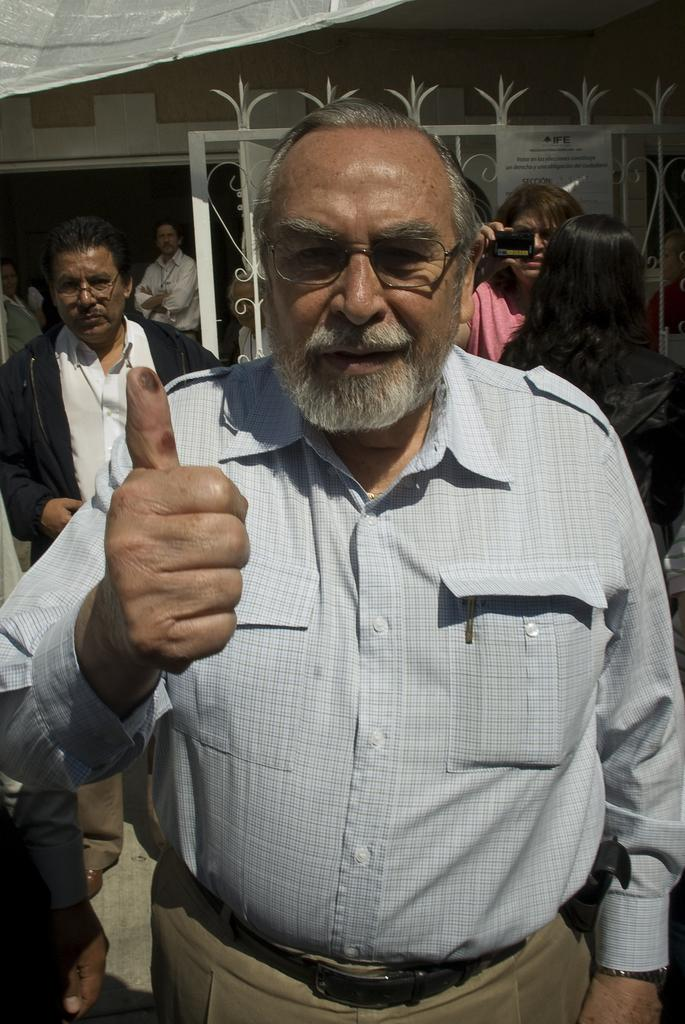How many people are in the image? There are people standing in the image, but the exact number is not specified. What is one person doing in the image? One person is holding a camera. What can be seen in the background of the image? There is a gate and a building visible in the background. What is the value of the feeling experienced by the person holding the camera in the image? There is no information about the feelings or emotions of the person holding the camera in the image, so it is impossible to determine their value. 